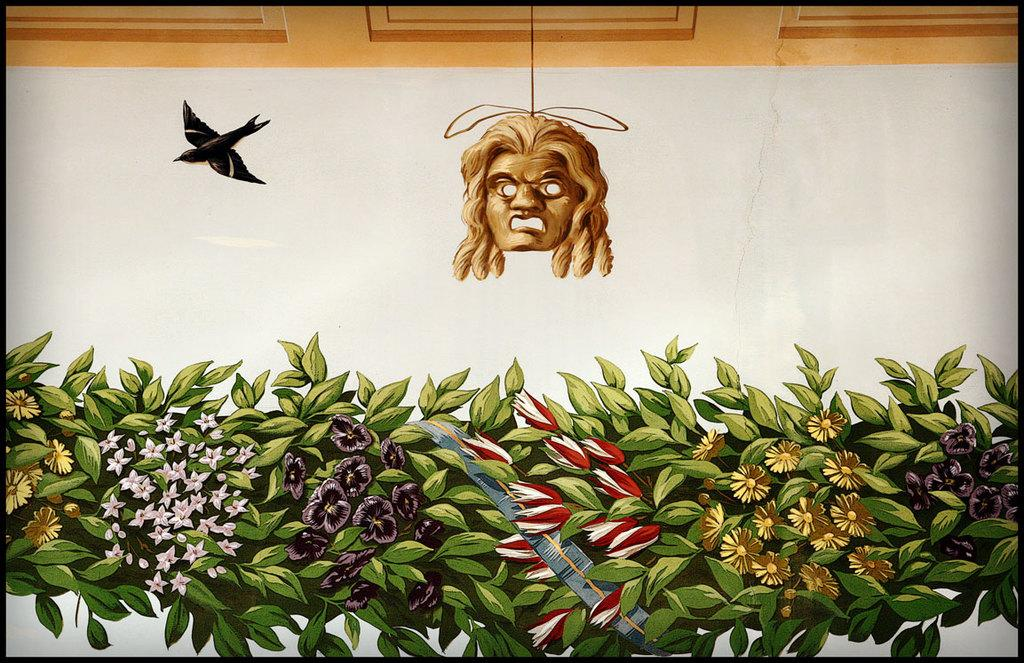What type of artwork is depicted in the image? The image appears to be a painting. What natural elements can be seen in the painting? There are leaves and flowers in the image. Where are the leaves and flowers located in the painting? The leaves and flowers are at the bottom of the image. What animal is present in the painting? There is a bird in the image. Where is the bird located in the painting? The bird is at the top of the image. How does the baby express anger in the image? There is no baby present in the image, so it is not possible to determine how a baby might express anger. 